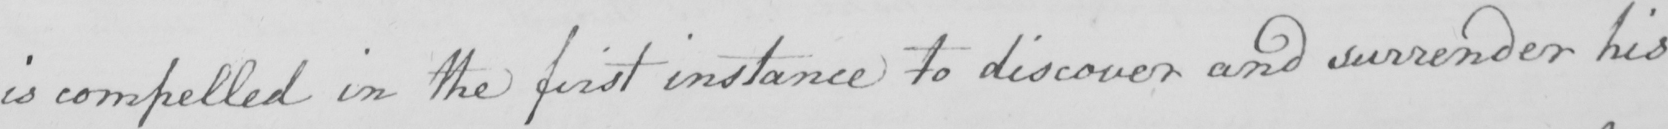Please transcribe the handwritten text in this image. is compelled in the first instance to discover and surrender his 